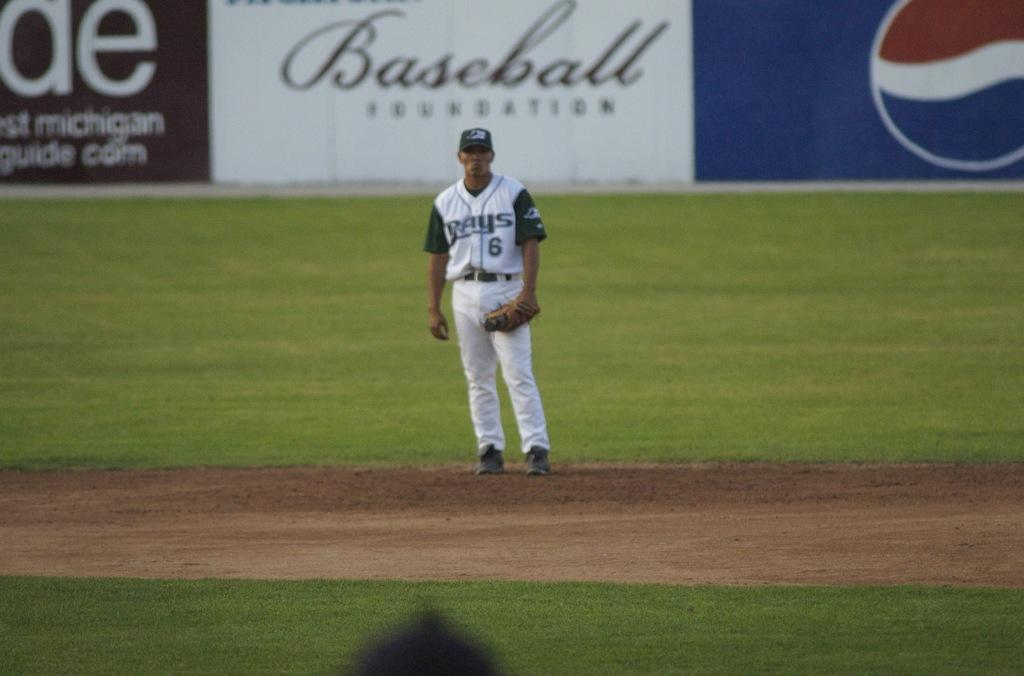<image>
Render a clear and concise summary of the photo. a baseball player from the rays standing on the field 